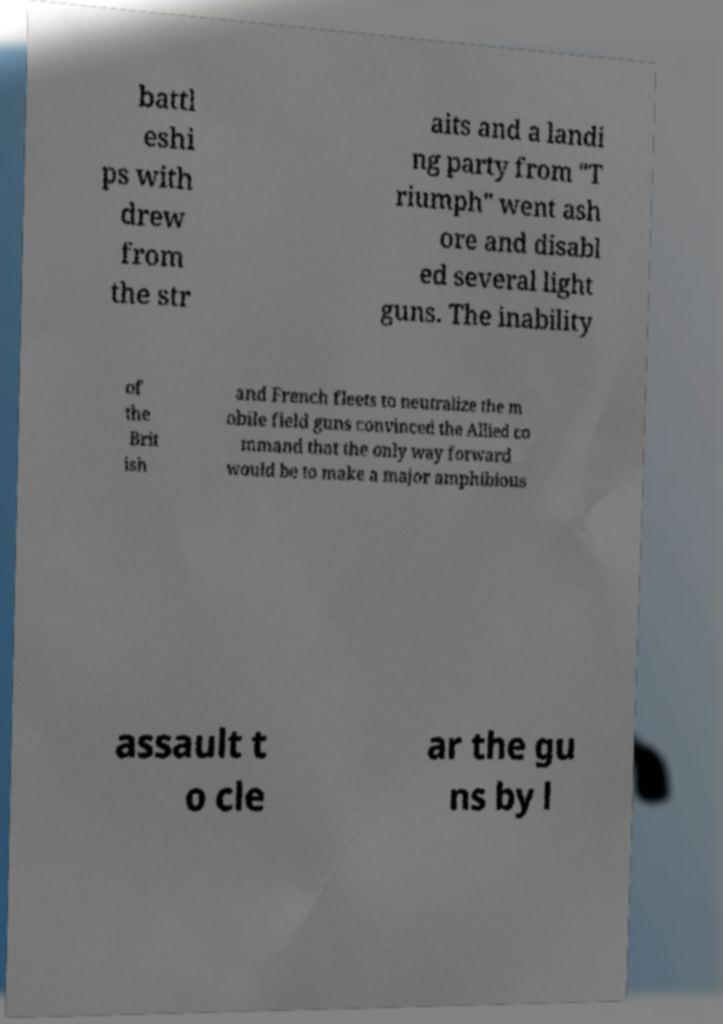Please read and relay the text visible in this image. What does it say? battl eshi ps with drew from the str aits and a landi ng party from "T riumph" went ash ore and disabl ed several light guns. The inability of the Brit ish and French fleets to neutralize the m obile field guns convinced the Allied co mmand that the only way forward would be to make a major amphibious assault t o cle ar the gu ns by l 